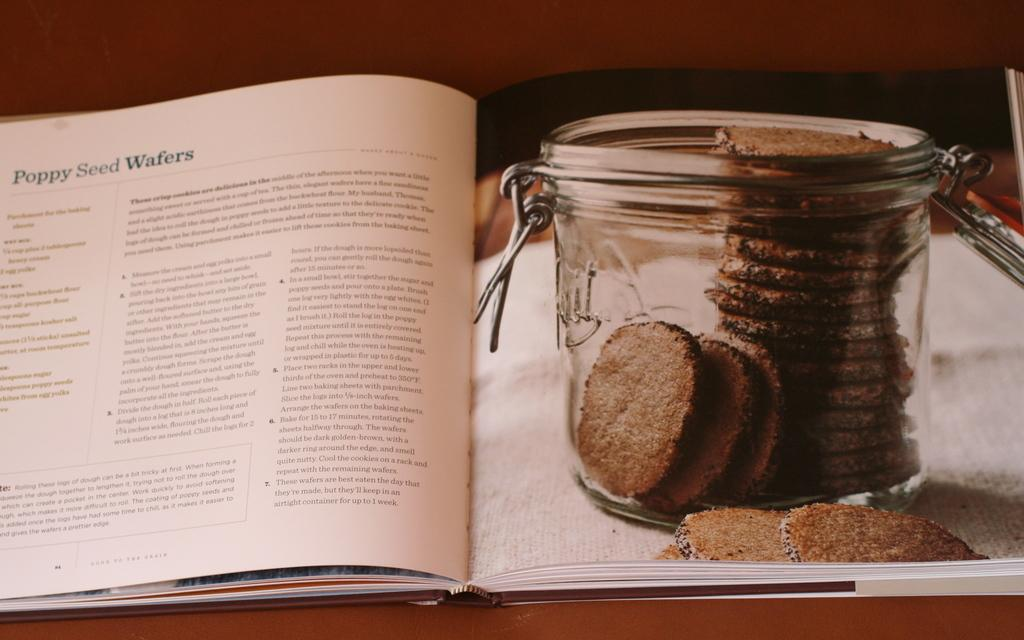<image>
Give a short and clear explanation of the subsequent image. A book open to a recipe for Poppy Seed Wafers. 